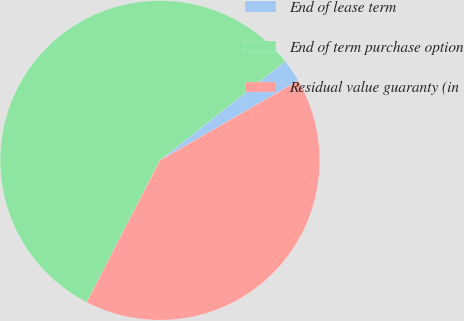Convert chart. <chart><loc_0><loc_0><loc_500><loc_500><pie_chart><fcel>End of lease term<fcel>End of term purchase option<fcel>Residual value guaranty (in<nl><fcel>2.33%<fcel>56.77%<fcel>40.9%<nl></chart> 